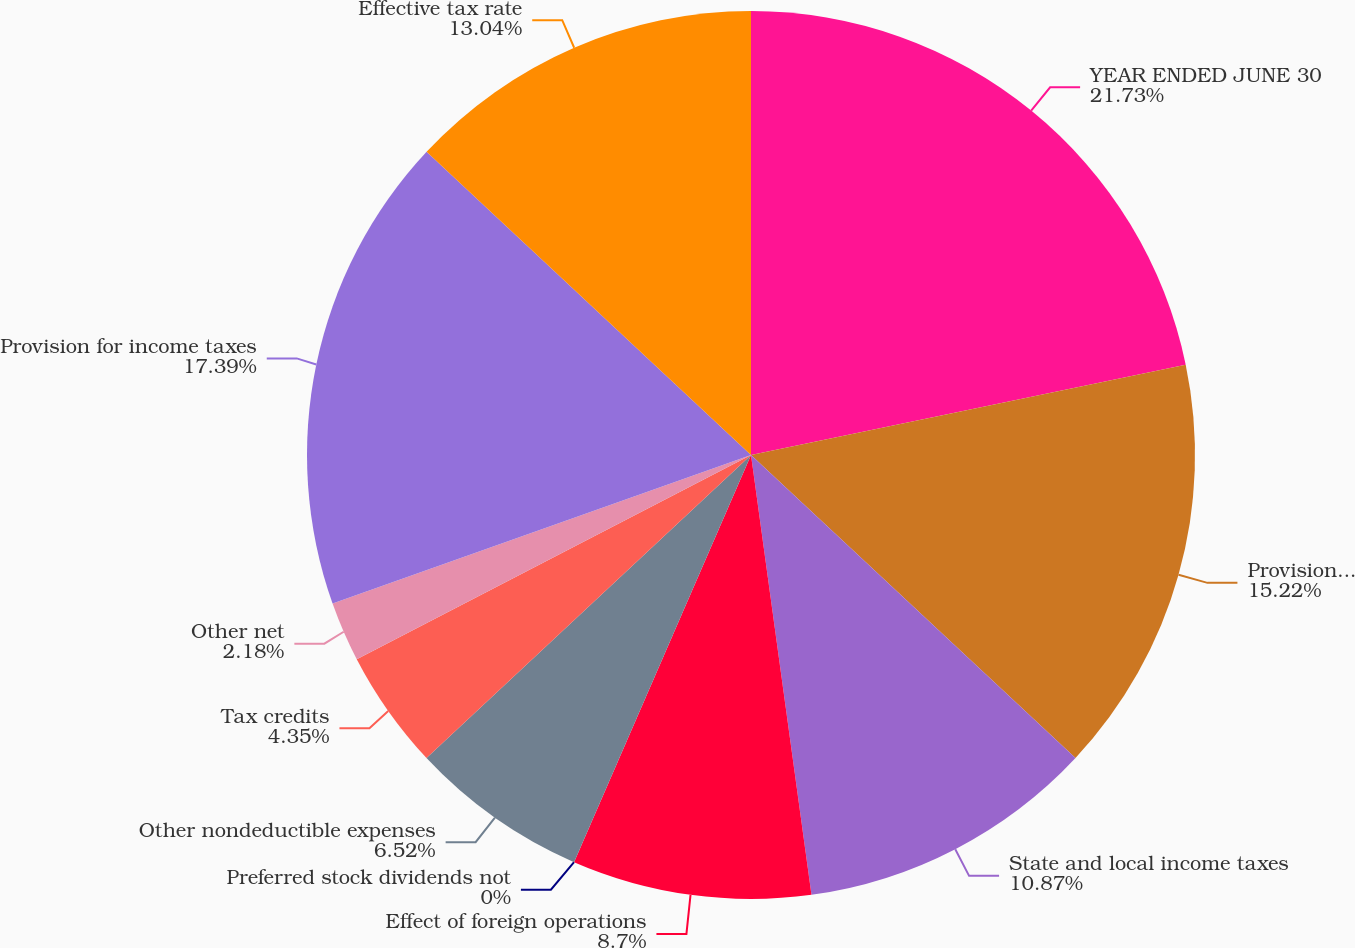Convert chart to OTSL. <chart><loc_0><loc_0><loc_500><loc_500><pie_chart><fcel>YEAR ENDED JUNE 30<fcel>Provision for income taxes at<fcel>State and local income taxes<fcel>Effect of foreign operations<fcel>Preferred stock dividends not<fcel>Other nondeductible expenses<fcel>Tax credits<fcel>Other net<fcel>Provision for income taxes<fcel>Effective tax rate<nl><fcel>21.74%<fcel>15.22%<fcel>10.87%<fcel>8.7%<fcel>0.0%<fcel>6.52%<fcel>4.35%<fcel>2.18%<fcel>17.39%<fcel>13.04%<nl></chart> 